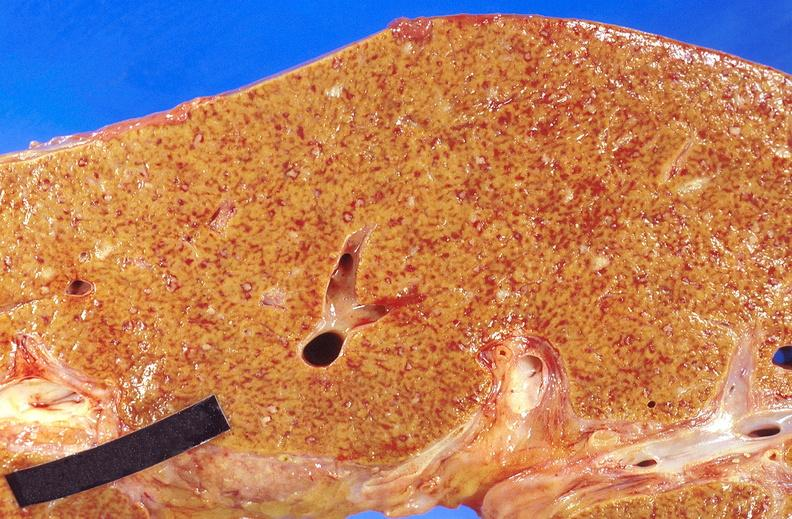what is present?
Answer the question using a single word or phrase. Hepatobiliary 